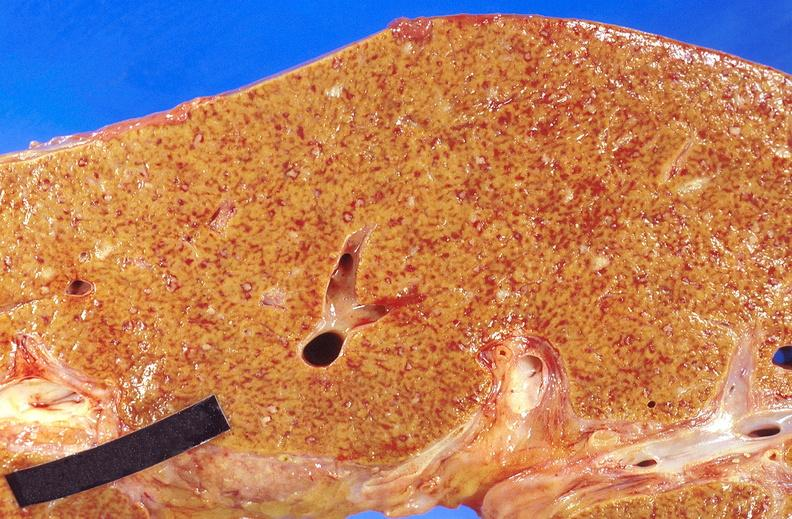what is present?
Answer the question using a single word or phrase. Hepatobiliary 